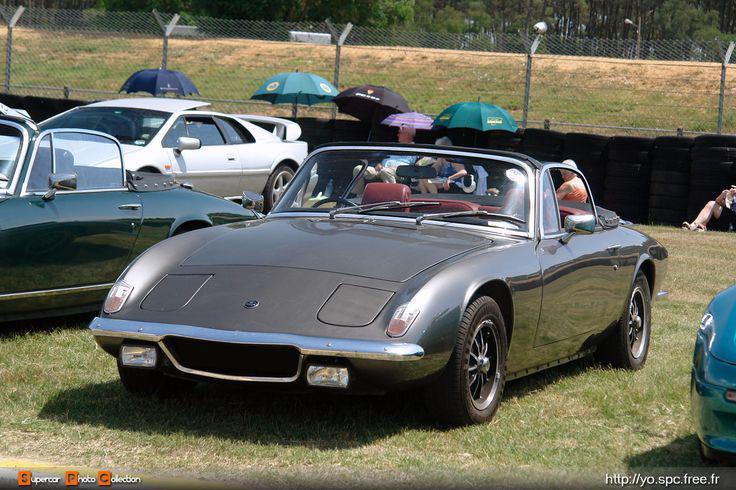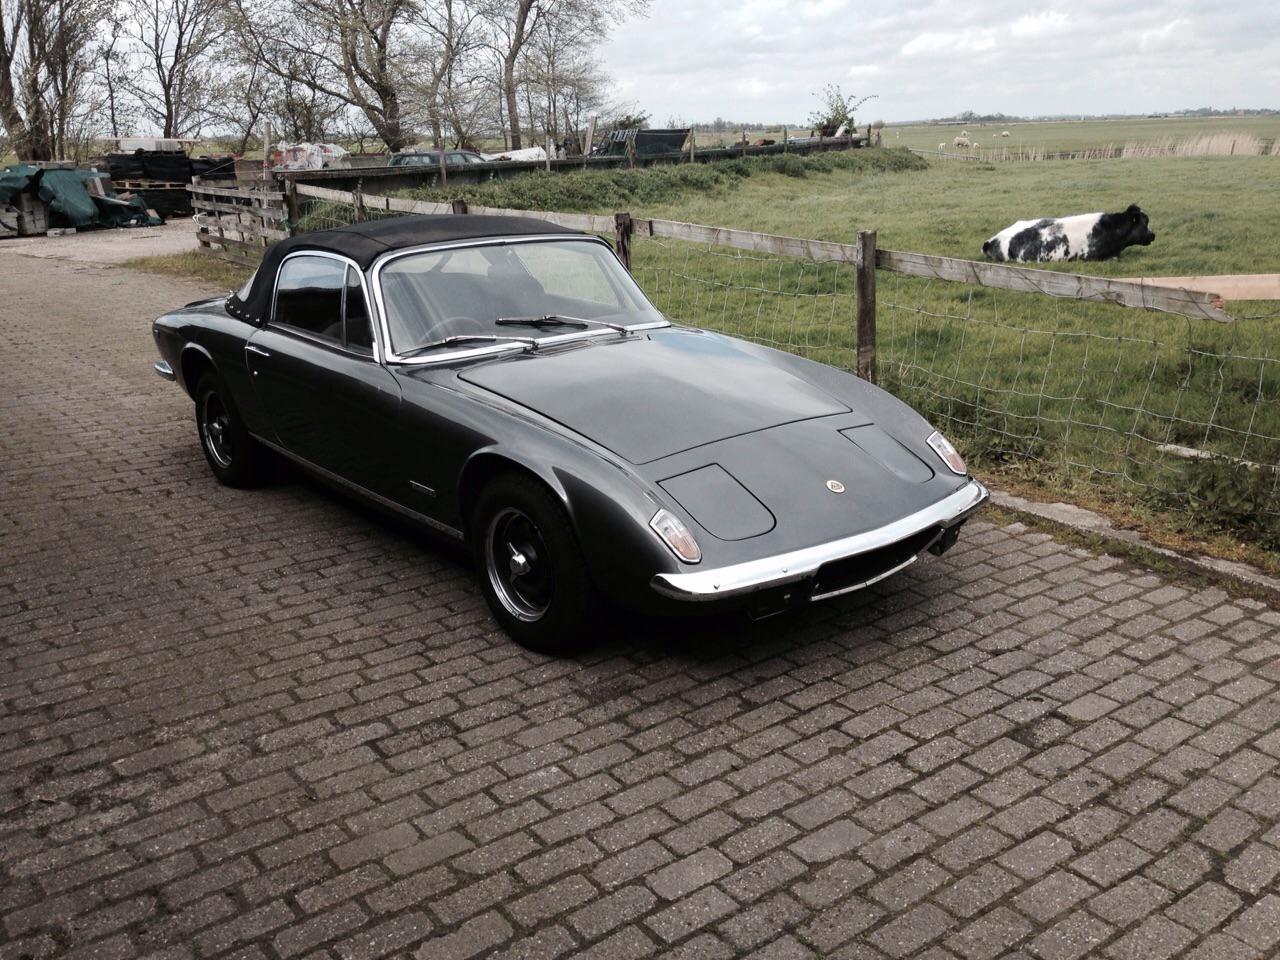The first image is the image on the left, the second image is the image on the right. For the images displayed, is the sentence "In one image, at least one car is parked on a brick pavement." factually correct? Answer yes or no. Yes. 